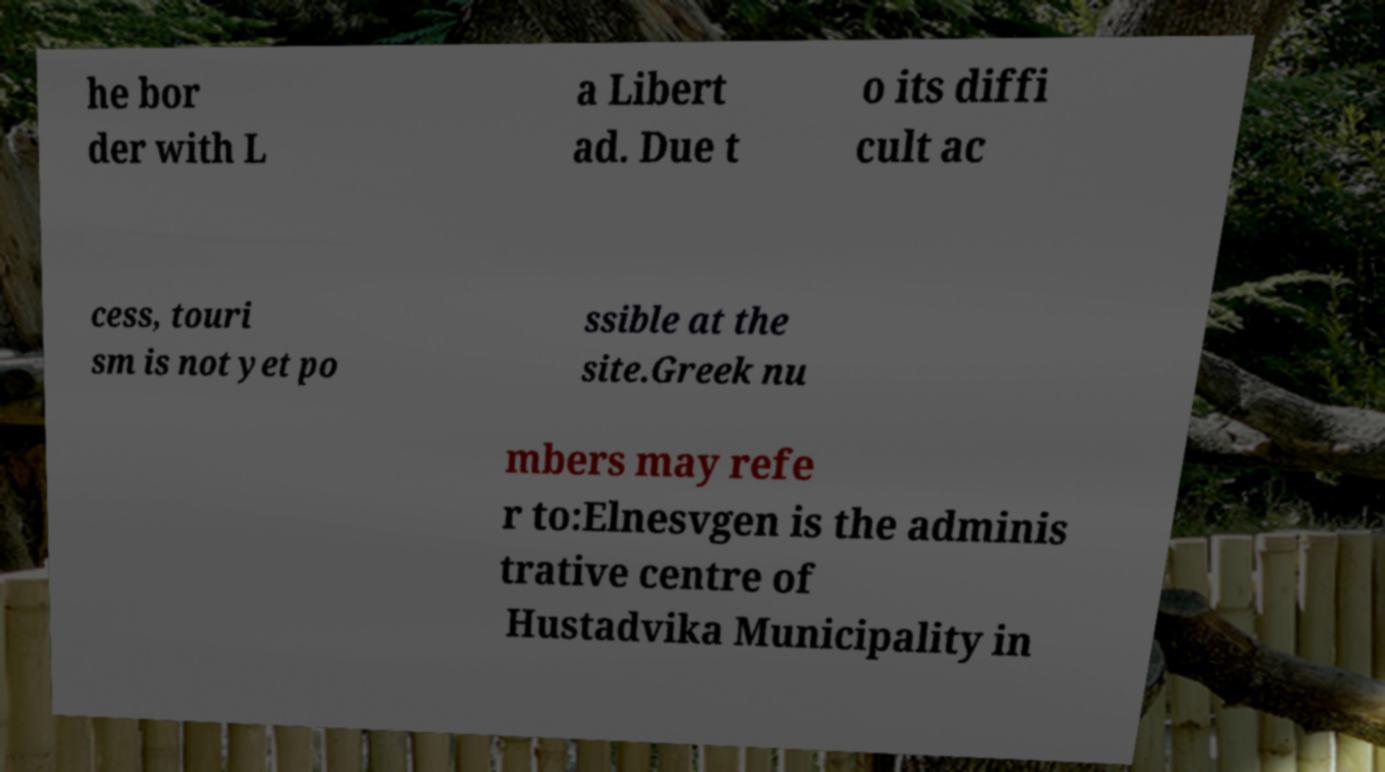Can you read and provide the text displayed in the image?This photo seems to have some interesting text. Can you extract and type it out for me? he bor der with L a Libert ad. Due t o its diffi cult ac cess, touri sm is not yet po ssible at the site.Greek nu mbers may refe r to:Elnesvgen is the adminis trative centre of Hustadvika Municipality in 